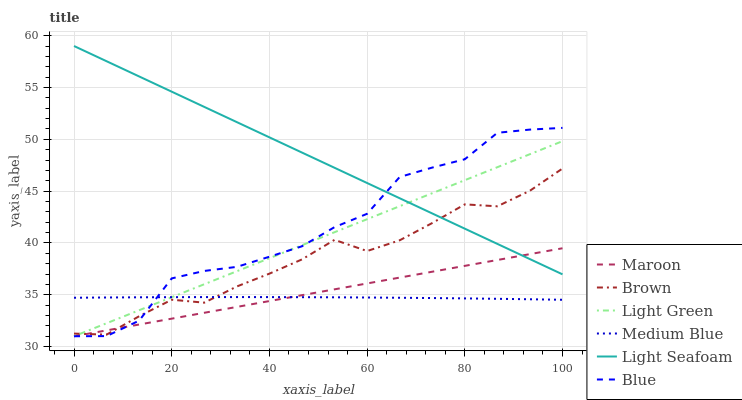Does Medium Blue have the minimum area under the curve?
Answer yes or no. Yes. Does Light Seafoam have the maximum area under the curve?
Answer yes or no. Yes. Does Brown have the minimum area under the curve?
Answer yes or no. No. Does Brown have the maximum area under the curve?
Answer yes or no. No. Is Maroon the smoothest?
Answer yes or no. Yes. Is Blue the roughest?
Answer yes or no. Yes. Is Brown the smoothest?
Answer yes or no. No. Is Brown the roughest?
Answer yes or no. No. Does Blue have the lowest value?
Answer yes or no. Yes. Does Brown have the lowest value?
Answer yes or no. No. Does Light Seafoam have the highest value?
Answer yes or no. Yes. Does Brown have the highest value?
Answer yes or no. No. Is Medium Blue less than Light Seafoam?
Answer yes or no. Yes. Is Light Seafoam greater than Medium Blue?
Answer yes or no. Yes. Does Light Green intersect Medium Blue?
Answer yes or no. Yes. Is Light Green less than Medium Blue?
Answer yes or no. No. Is Light Green greater than Medium Blue?
Answer yes or no. No. Does Medium Blue intersect Light Seafoam?
Answer yes or no. No. 